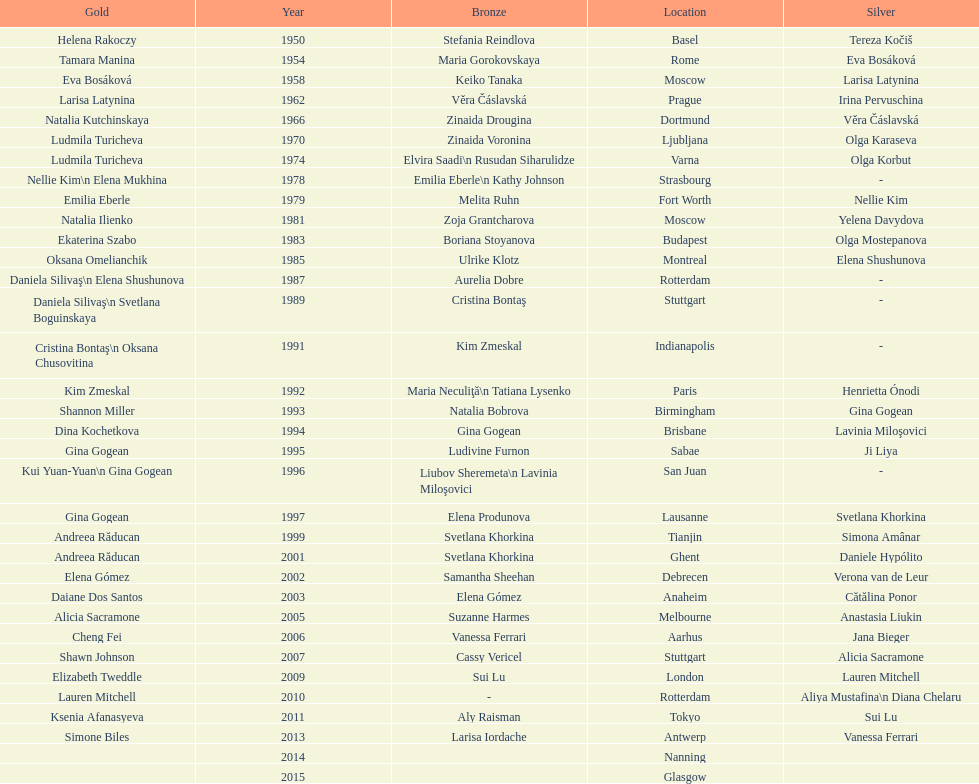How many consecutive floor exercise gold medals did romanian star andreea raducan win at the world championships? 2. 